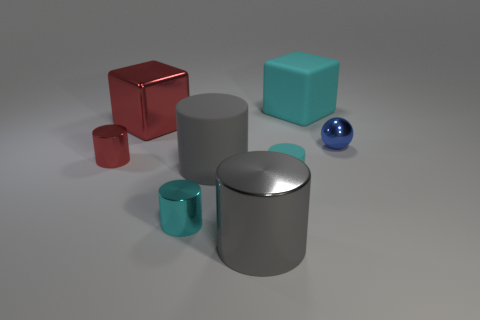Add 2 big gray metallic cylinders. How many objects exist? 10 Subtract all large cylinders. How many cylinders are left? 3 Subtract all red blocks. How many blocks are left? 1 Subtract 5 cylinders. How many cylinders are left? 0 Add 2 gray objects. How many gray objects are left? 4 Add 3 small shiny cylinders. How many small shiny cylinders exist? 5 Subtract 2 cyan cylinders. How many objects are left? 6 Subtract all spheres. How many objects are left? 7 Subtract all purple spheres. Subtract all gray cylinders. How many spheres are left? 1 Subtract all red blocks. How many yellow balls are left? 0 